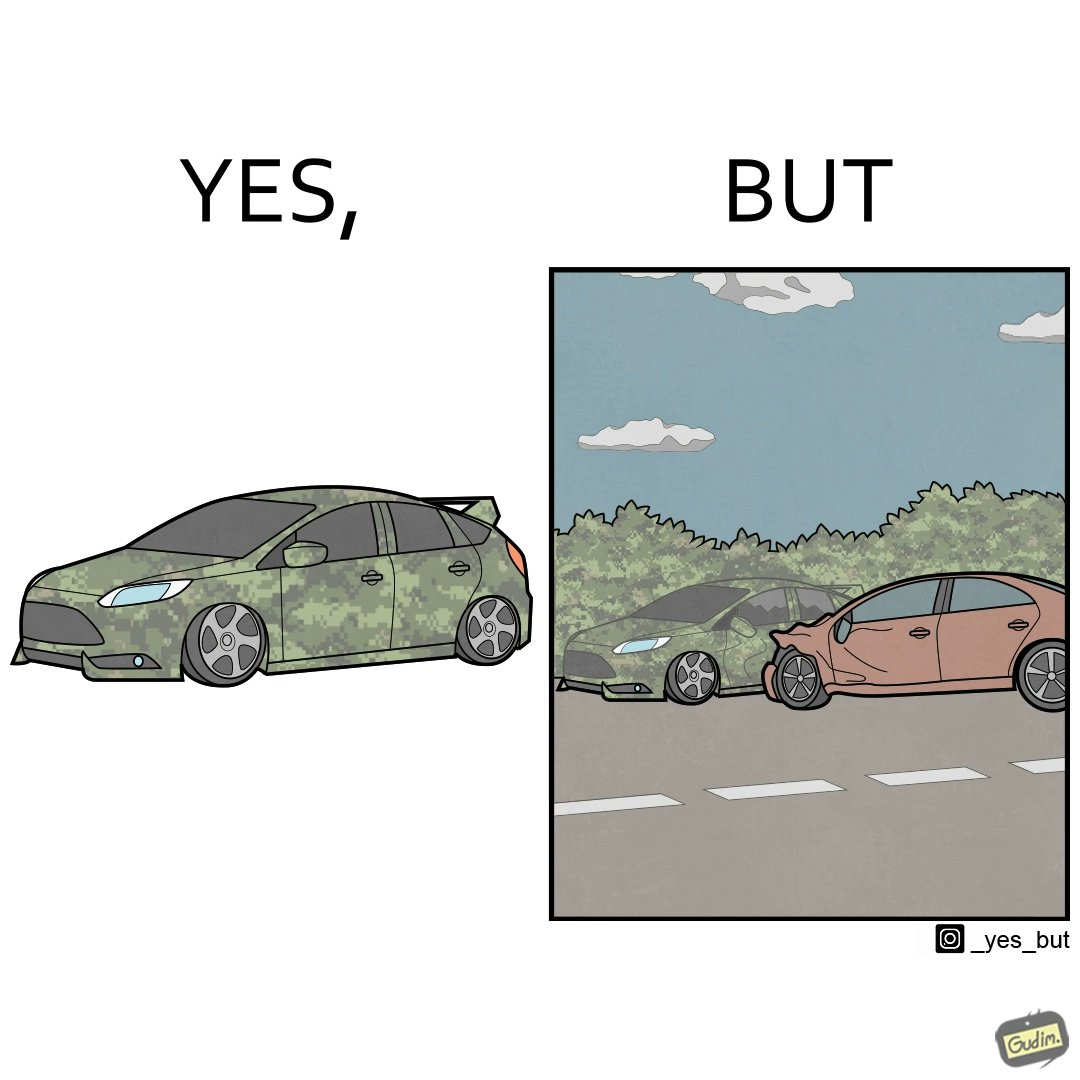Explain the humor or irony in this image. The image is ironic, because in the left image a car is painted in camouflage color but in the right image the same car is getting involved in accident to due to its color as other drivers face difficulty in recognizing the colors 